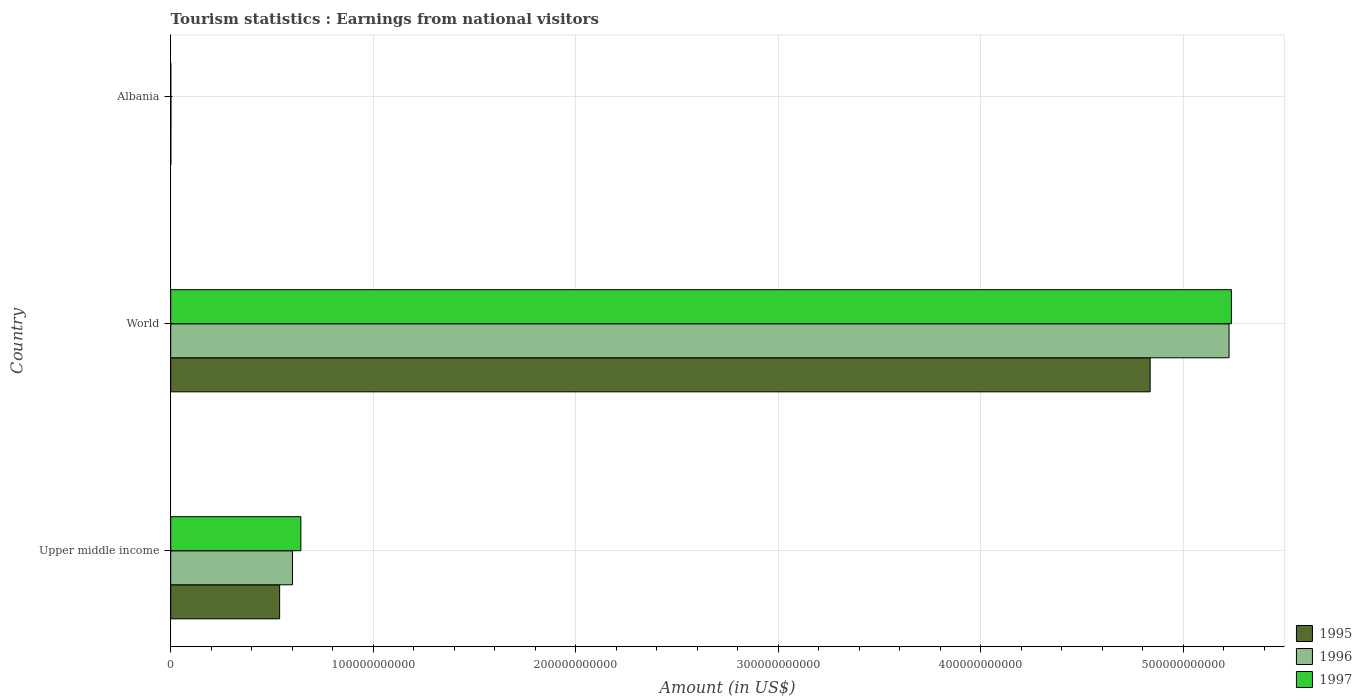Are the number of bars on each tick of the Y-axis equal?
Your response must be concise. Yes. How many bars are there on the 1st tick from the top?
Keep it short and to the point. 3. What is the label of the 2nd group of bars from the top?
Make the answer very short. World. In how many cases, is the number of bars for a given country not equal to the number of legend labels?
Your answer should be very brief. 0. What is the earnings from national visitors in 1995 in Albania?
Keep it short and to the point. 7.04e+07. Across all countries, what is the maximum earnings from national visitors in 1995?
Ensure brevity in your answer.  4.84e+11. Across all countries, what is the minimum earnings from national visitors in 1995?
Your answer should be very brief. 7.04e+07. In which country was the earnings from national visitors in 1995 minimum?
Give a very brief answer. Albania. What is the total earnings from national visitors in 1996 in the graph?
Provide a short and direct response. 5.83e+11. What is the difference between the earnings from national visitors in 1996 in Albania and that in World?
Your answer should be very brief. -5.23e+11. What is the difference between the earnings from national visitors in 1995 in Albania and the earnings from national visitors in 1997 in Upper middle income?
Your response must be concise. -6.42e+1. What is the average earnings from national visitors in 1996 per country?
Ensure brevity in your answer.  1.94e+11. What is the difference between the earnings from national visitors in 1996 and earnings from national visitors in 1997 in World?
Ensure brevity in your answer.  -1.17e+09. In how many countries, is the earnings from national visitors in 1997 greater than 40000000000 US$?
Your answer should be compact. 2. What is the ratio of the earnings from national visitors in 1996 in Upper middle income to that in World?
Offer a terse response. 0.12. What is the difference between the highest and the second highest earnings from national visitors in 1997?
Your response must be concise. 4.60e+11. What is the difference between the highest and the lowest earnings from national visitors in 1996?
Keep it short and to the point. 5.23e+11. In how many countries, is the earnings from national visitors in 1996 greater than the average earnings from national visitors in 1996 taken over all countries?
Provide a succinct answer. 1. Is the sum of the earnings from national visitors in 1997 in Upper middle income and World greater than the maximum earnings from national visitors in 1995 across all countries?
Ensure brevity in your answer.  Yes. Is it the case that in every country, the sum of the earnings from national visitors in 1996 and earnings from national visitors in 1995 is greater than the earnings from national visitors in 1997?
Your answer should be very brief. Yes. How many bars are there?
Your answer should be compact. 9. What is the difference between two consecutive major ticks on the X-axis?
Offer a terse response. 1.00e+11. Does the graph contain any zero values?
Ensure brevity in your answer.  No. Does the graph contain grids?
Offer a terse response. Yes. What is the title of the graph?
Your answer should be compact. Tourism statistics : Earnings from national visitors. What is the Amount (in US$) in 1995 in Upper middle income?
Give a very brief answer. 5.38e+1. What is the Amount (in US$) of 1996 in Upper middle income?
Ensure brevity in your answer.  6.01e+1. What is the Amount (in US$) of 1997 in Upper middle income?
Give a very brief answer. 6.43e+1. What is the Amount (in US$) of 1995 in World?
Make the answer very short. 4.84e+11. What is the Amount (in US$) in 1996 in World?
Give a very brief answer. 5.23e+11. What is the Amount (in US$) in 1997 in World?
Offer a very short reply. 5.24e+11. What is the Amount (in US$) of 1995 in Albania?
Make the answer very short. 7.04e+07. What is the Amount (in US$) of 1996 in Albania?
Provide a short and direct response. 9.38e+07. What is the Amount (in US$) in 1997 in Albania?
Your answer should be very brief. 3.36e+07. Across all countries, what is the maximum Amount (in US$) of 1995?
Ensure brevity in your answer.  4.84e+11. Across all countries, what is the maximum Amount (in US$) of 1996?
Offer a terse response. 5.23e+11. Across all countries, what is the maximum Amount (in US$) of 1997?
Give a very brief answer. 5.24e+11. Across all countries, what is the minimum Amount (in US$) of 1995?
Ensure brevity in your answer.  7.04e+07. Across all countries, what is the minimum Amount (in US$) of 1996?
Give a very brief answer. 9.38e+07. Across all countries, what is the minimum Amount (in US$) of 1997?
Provide a succinct answer. 3.36e+07. What is the total Amount (in US$) of 1995 in the graph?
Offer a terse response. 5.38e+11. What is the total Amount (in US$) of 1996 in the graph?
Your answer should be very brief. 5.83e+11. What is the total Amount (in US$) of 1997 in the graph?
Provide a succinct answer. 5.88e+11. What is the difference between the Amount (in US$) of 1995 in Upper middle income and that in World?
Provide a succinct answer. -4.30e+11. What is the difference between the Amount (in US$) in 1996 in Upper middle income and that in World?
Provide a short and direct response. -4.63e+11. What is the difference between the Amount (in US$) of 1997 in Upper middle income and that in World?
Provide a succinct answer. -4.60e+11. What is the difference between the Amount (in US$) of 1995 in Upper middle income and that in Albania?
Your answer should be very brief. 5.37e+1. What is the difference between the Amount (in US$) in 1996 in Upper middle income and that in Albania?
Give a very brief answer. 6.00e+1. What is the difference between the Amount (in US$) of 1997 in Upper middle income and that in Albania?
Make the answer very short. 6.42e+1. What is the difference between the Amount (in US$) in 1995 in World and that in Albania?
Your answer should be very brief. 4.84e+11. What is the difference between the Amount (in US$) in 1996 in World and that in Albania?
Your response must be concise. 5.23e+11. What is the difference between the Amount (in US$) in 1997 in World and that in Albania?
Your response must be concise. 5.24e+11. What is the difference between the Amount (in US$) in 1995 in Upper middle income and the Amount (in US$) in 1996 in World?
Give a very brief answer. -4.69e+11. What is the difference between the Amount (in US$) in 1995 in Upper middle income and the Amount (in US$) in 1997 in World?
Your answer should be compact. -4.70e+11. What is the difference between the Amount (in US$) of 1996 in Upper middle income and the Amount (in US$) of 1997 in World?
Your response must be concise. -4.64e+11. What is the difference between the Amount (in US$) in 1995 in Upper middle income and the Amount (in US$) in 1996 in Albania?
Keep it short and to the point. 5.37e+1. What is the difference between the Amount (in US$) of 1995 in Upper middle income and the Amount (in US$) of 1997 in Albania?
Your answer should be very brief. 5.38e+1. What is the difference between the Amount (in US$) of 1996 in Upper middle income and the Amount (in US$) of 1997 in Albania?
Give a very brief answer. 6.01e+1. What is the difference between the Amount (in US$) in 1995 in World and the Amount (in US$) in 1996 in Albania?
Ensure brevity in your answer.  4.84e+11. What is the difference between the Amount (in US$) of 1995 in World and the Amount (in US$) of 1997 in Albania?
Your answer should be compact. 4.84e+11. What is the difference between the Amount (in US$) of 1996 in World and the Amount (in US$) of 1997 in Albania?
Your answer should be very brief. 5.23e+11. What is the average Amount (in US$) of 1995 per country?
Keep it short and to the point. 1.79e+11. What is the average Amount (in US$) in 1996 per country?
Make the answer very short. 1.94e+11. What is the average Amount (in US$) in 1997 per country?
Ensure brevity in your answer.  1.96e+11. What is the difference between the Amount (in US$) in 1995 and Amount (in US$) in 1996 in Upper middle income?
Provide a succinct answer. -6.33e+09. What is the difference between the Amount (in US$) of 1995 and Amount (in US$) of 1997 in Upper middle income?
Provide a succinct answer. -1.05e+1. What is the difference between the Amount (in US$) of 1996 and Amount (in US$) of 1997 in Upper middle income?
Keep it short and to the point. -4.15e+09. What is the difference between the Amount (in US$) of 1995 and Amount (in US$) of 1996 in World?
Your answer should be compact. -3.90e+1. What is the difference between the Amount (in US$) of 1995 and Amount (in US$) of 1997 in World?
Give a very brief answer. -4.01e+1. What is the difference between the Amount (in US$) of 1996 and Amount (in US$) of 1997 in World?
Your answer should be very brief. -1.17e+09. What is the difference between the Amount (in US$) of 1995 and Amount (in US$) of 1996 in Albania?
Make the answer very short. -2.34e+07. What is the difference between the Amount (in US$) in 1995 and Amount (in US$) in 1997 in Albania?
Give a very brief answer. 3.68e+07. What is the difference between the Amount (in US$) in 1996 and Amount (in US$) in 1997 in Albania?
Offer a terse response. 6.02e+07. What is the ratio of the Amount (in US$) of 1995 in Upper middle income to that in World?
Your response must be concise. 0.11. What is the ratio of the Amount (in US$) of 1996 in Upper middle income to that in World?
Offer a terse response. 0.12. What is the ratio of the Amount (in US$) in 1997 in Upper middle income to that in World?
Ensure brevity in your answer.  0.12. What is the ratio of the Amount (in US$) in 1995 in Upper middle income to that in Albania?
Offer a very short reply. 764.16. What is the ratio of the Amount (in US$) of 1996 in Upper middle income to that in Albania?
Your answer should be compact. 641.02. What is the ratio of the Amount (in US$) in 1997 in Upper middle income to that in Albania?
Provide a short and direct response. 1912.87. What is the ratio of the Amount (in US$) in 1995 in World to that in Albania?
Ensure brevity in your answer.  6871.01. What is the ratio of the Amount (in US$) of 1996 in World to that in Albania?
Offer a terse response. 5572.3. What is the ratio of the Amount (in US$) of 1997 in World to that in Albania?
Keep it short and to the point. 1.56e+04. What is the difference between the highest and the second highest Amount (in US$) of 1995?
Your answer should be compact. 4.30e+11. What is the difference between the highest and the second highest Amount (in US$) in 1996?
Your answer should be very brief. 4.63e+11. What is the difference between the highest and the second highest Amount (in US$) of 1997?
Provide a short and direct response. 4.60e+11. What is the difference between the highest and the lowest Amount (in US$) in 1995?
Your response must be concise. 4.84e+11. What is the difference between the highest and the lowest Amount (in US$) in 1996?
Make the answer very short. 5.23e+11. What is the difference between the highest and the lowest Amount (in US$) of 1997?
Provide a succinct answer. 5.24e+11. 